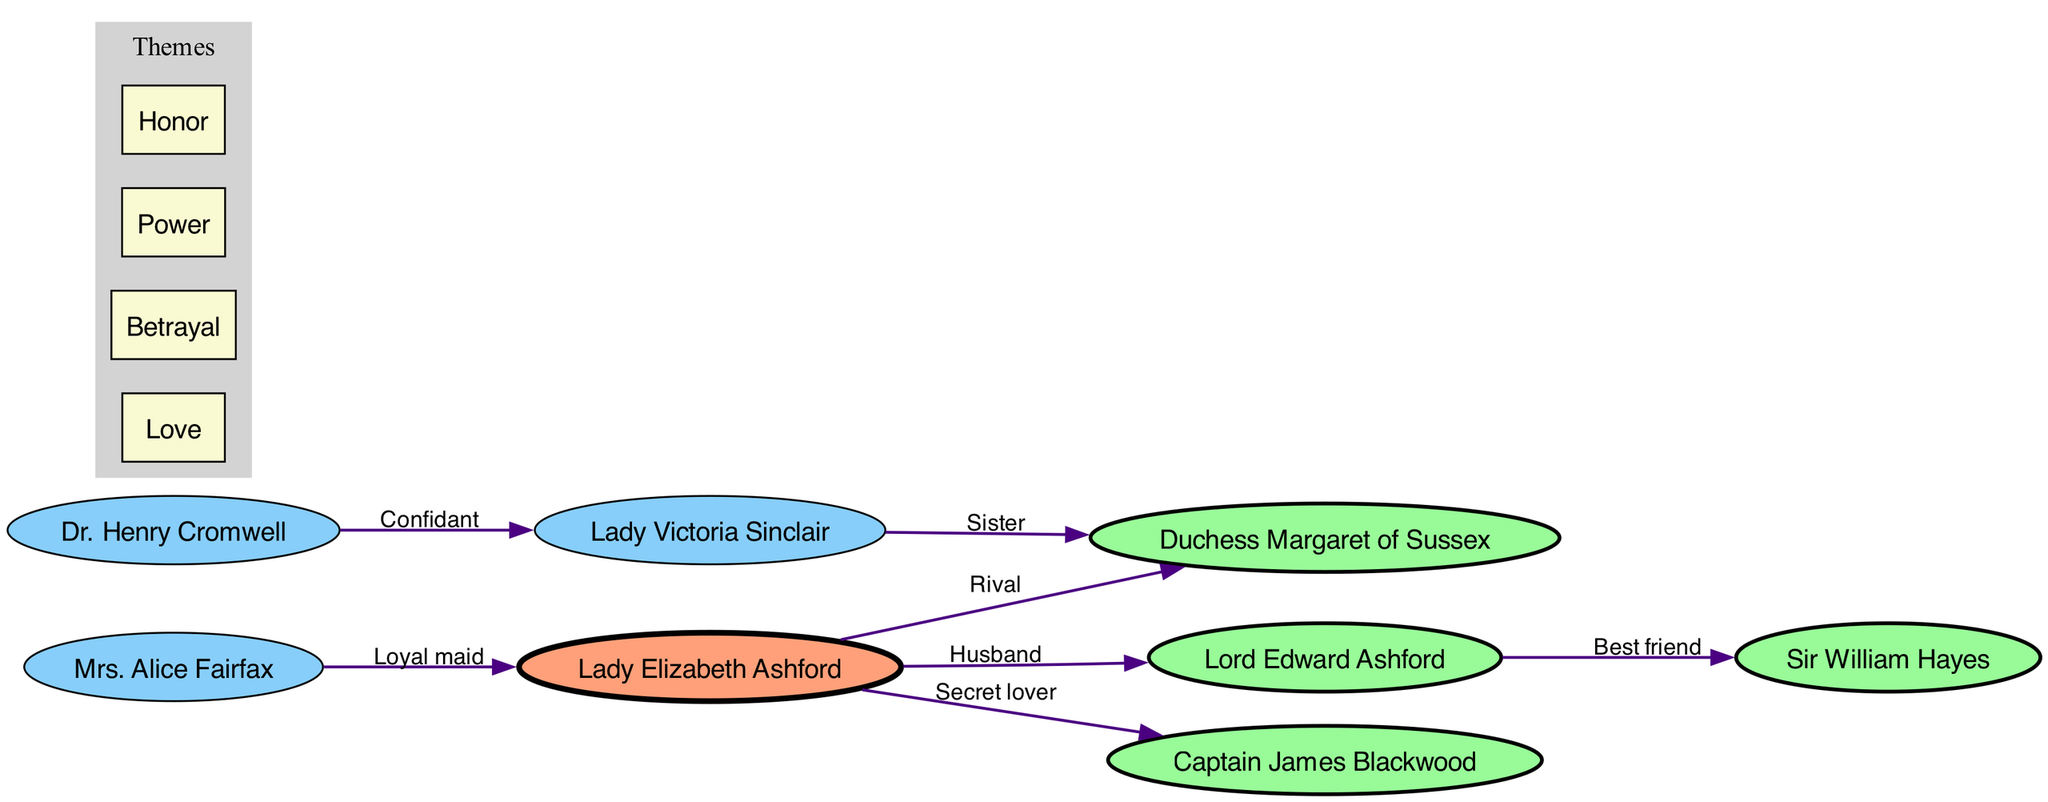What is the central character in the diagram? The central character is identified at the center of the diagram, visually distinct from other characters. In this case, it is "Lady Elizabeth Ashford."
Answer: Lady Elizabeth Ashford How many primary characters are in the diagram? The primary characters can be counted by observing the group of names that are connected directly to the central character. There are four primary characters: "Lord Edward Ashford," "Captain James Blackwood," "Duchess Margaret of Sussex," and "Sir William Hayes."
Answer: 4 What type of relationship exists between Lady Elizabeth Ashford and Captain James Blackwood? By examining the edge connecting "Lady Elizabeth Ashford" and "Captain James Blackwood," the label indicates the type of relationship. This relationship is described as a "Secret lover."
Answer: Secret lover Who is the best friend of Lord Edward Ashford? The diagram clearly shows a relationship originating from "Lord Edward Ashford" to "Sir William Hayes," labeled as "Best friend." Therefore, "Sir William Hayes" holds that relationship.
Answer: Sir William Hayes What is the relationship type between Mrs. Alice Fairfax and Lady Elizabeth Ashford? The edge connecting these two characters shows the relationship label. This indicates that "Mrs. Alice Fairfax" serves as a "Loyal maid" to "Lady Elizabeth Ashford."
Answer: Loyal maid How many secondary characters are depicted in the diagram? The secondary characters can be assessed by counting the names designated as secondary within the character categories. There are three secondary characters: "Mrs. Alice Fairfax," "Dr. Henry Cromwell," and "Lady Victoria Sinclair."
Answer: 3 Which character is a rival to Lady Elizabeth Ashford? The diagram indicates the type of relationship between characters, and for "Lady Elizabeth Ashford," the edge pointing to "Duchess Margaret of Sussex" specifies the relationship as "Rival."
Answer: Duchess Margaret of Sussex What theme is associated with the relationships depicted in the diagram? The themes are collectively illustrated in a dedicated section of the diagram, mentioning ideas that encapsulate the narrative. They include "Love," "Betrayal," "Power," and "Honor."
Answer: Love, Betrayal, Power, Honor What is the familial relationship between Lady Victoria Sinclair and Duchess Margaret of Sussex? The connection labeled between "Lady Victoria Sinclair" and "Duchess Margaret of Sussex" indicates that they share a "Sister" relationship, identifying their familial bond.
Answer: Sister 